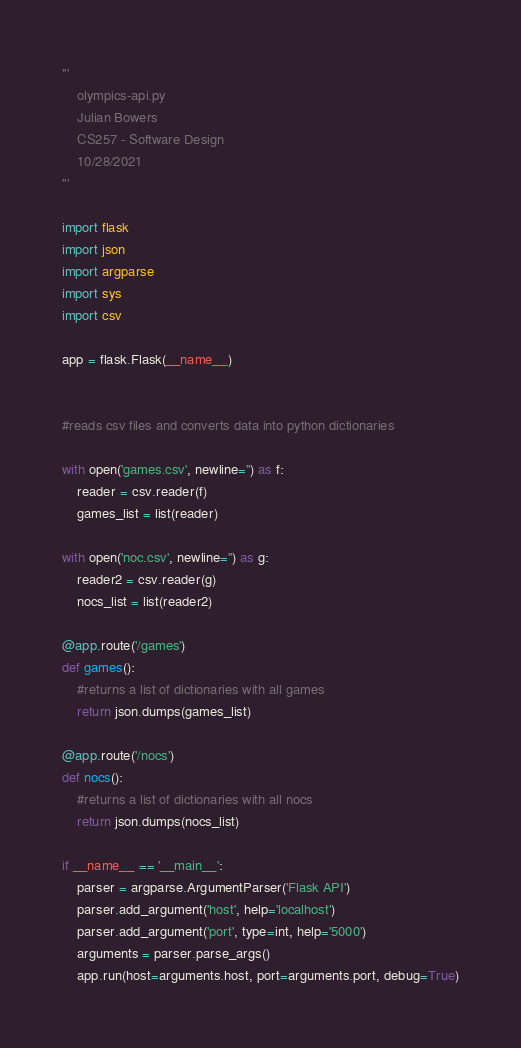<code> <loc_0><loc_0><loc_500><loc_500><_Python_>'''
	olympics-api.py
	Julian Bowers
	CS257 - Software Design
	10/28/2021
'''

import flask
import json
import argparse
import sys
import csv

app = flask.Flask(__name__)


#reads csv files and converts data into python dictionaries

with open('games.csv', newline='') as f:
	reader = csv.reader(f)
	games_list = list(reader)
	
with open('noc.csv', newline='') as g:
	reader2 = csv.reader(g)
	nocs_list = list(reader2)

@app.route('/games')
def games():
	#returns a list of dictionaries with all games
	return json.dumps(games_list)

@app.route('/nocs')
def nocs():
	#returns a list of dictionaries with all nocs
	return json.dumps(nocs_list)

if __name__ == '__main__':
	parser = argparse.ArgumentParser('Flask API')
	parser.add_argument('host', help='localhost')
	parser.add_argument('port', type=int, help='5000')
	arguments = parser.parse_args()
	app.run(host=arguments.host, port=arguments.port, debug=True)</code> 